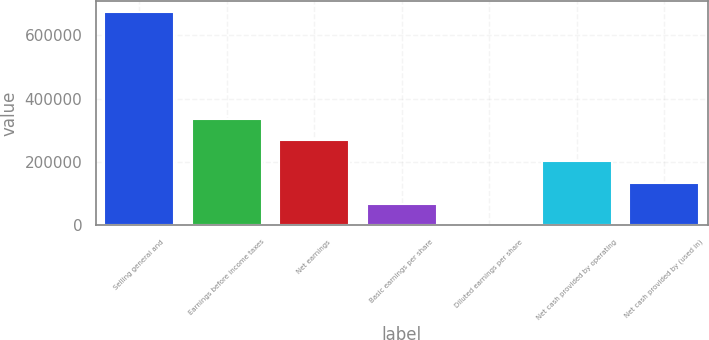Convert chart to OTSL. <chart><loc_0><loc_0><loc_500><loc_500><bar_chart><fcel>Selling general and<fcel>Earnings before income taxes<fcel>Net earnings<fcel>Basic earnings per share<fcel>Diluted earnings per share<fcel>Net cash provided by operating<fcel>Net cash provided by (used in)<nl><fcel>674370<fcel>337185<fcel>269748<fcel>67437.6<fcel>0.63<fcel>202311<fcel>134875<nl></chart> 